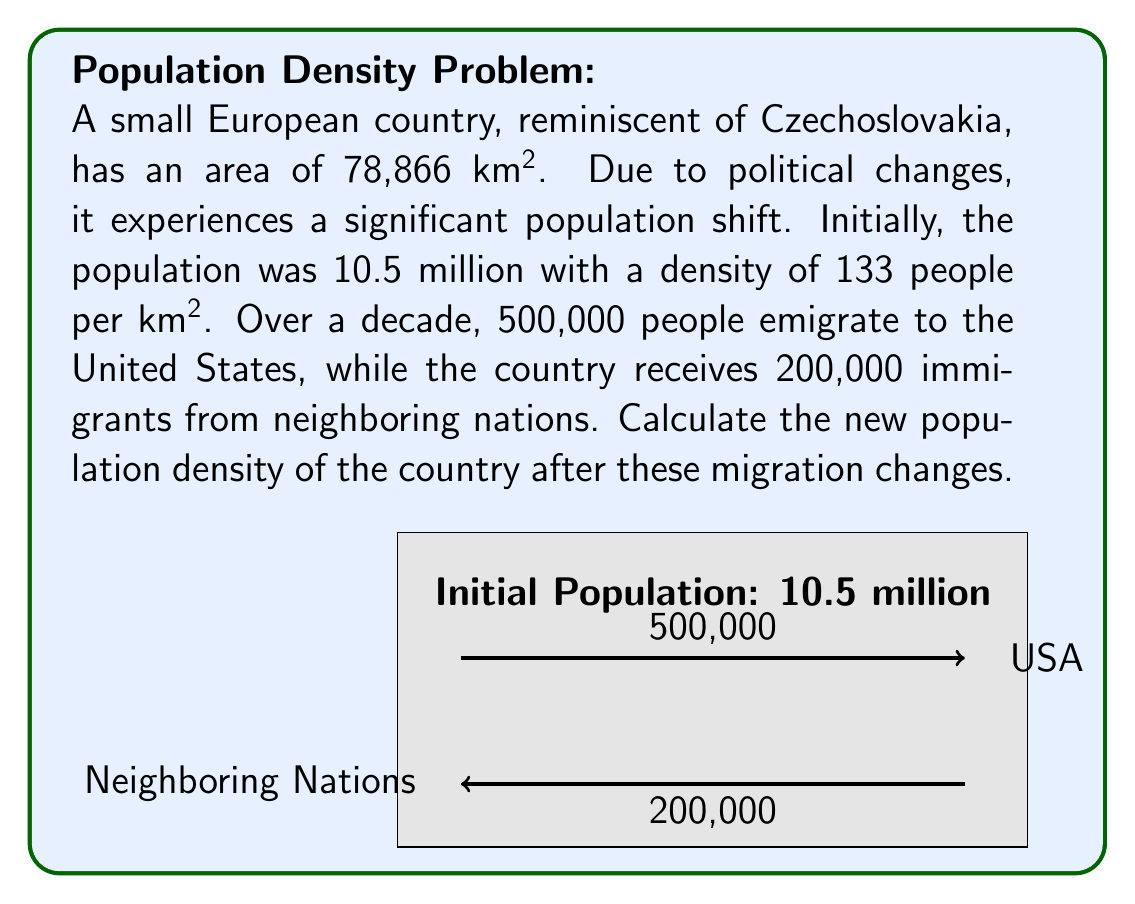What is the answer to this math problem? Let's approach this step-by-step:

1) First, let's calculate the new population after the migration changes:
   Initial population: 10.5 million
   Emigration: 500,000
   Immigration: 200,000
   
   New population = $10,500,000 - 500,000 + 200,000 = 10,200,000$

2) Now, we need to calculate the new population density. The formula for population density is:

   $$\text{Population Density} = \frac{\text{Population}}{\text{Area}}$$

3) We know the area remains constant at 78,866 km². Let's plug in our values:

   $$\text{New Population Density} = \frac{10,200,000}{78,866}$$

4) Performing the division:

   $$\text{New Population Density} \approx 129.33 \text{ people per km²}$$

5) Rounding to the nearest whole number:

   $$\text{New Population Density} \approx 129 \text{ people per km²}$$

Thus, the new population density of the country after the migration changes is approximately 129 people per km².
Answer: 129 people/km² 